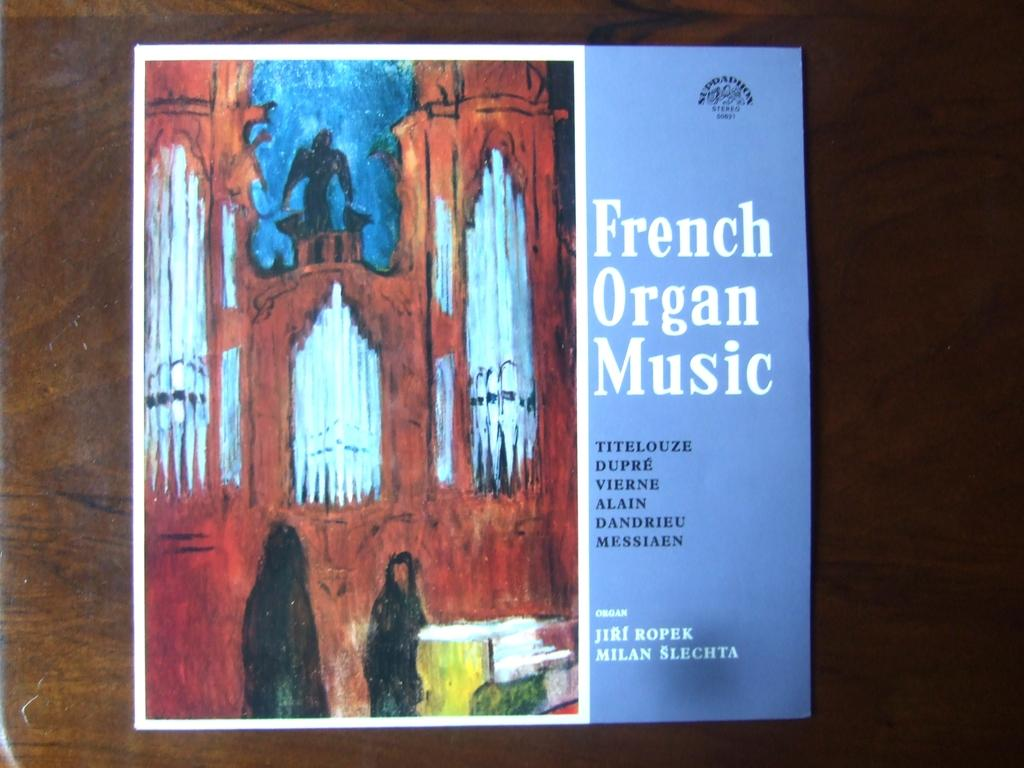<image>
Present a compact description of the photo's key features. Album cover that says French Organ Music in white letters. 